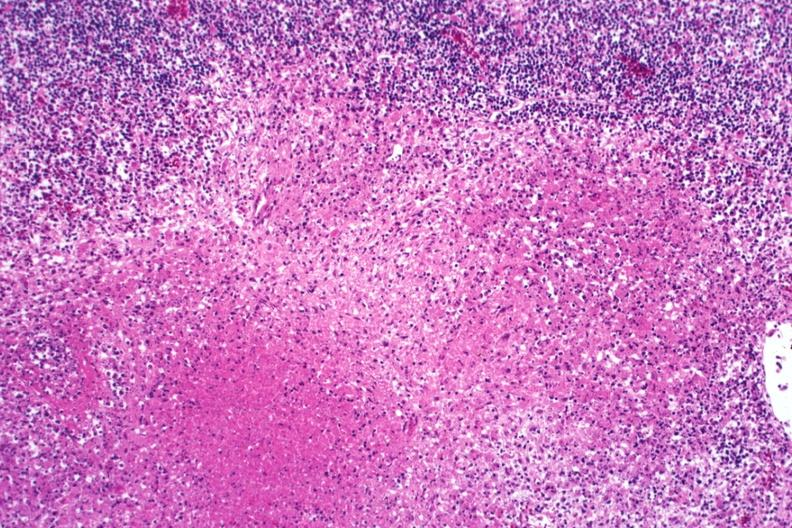s tuberculosis present?
Answer the question using a single word or phrase. Yes 